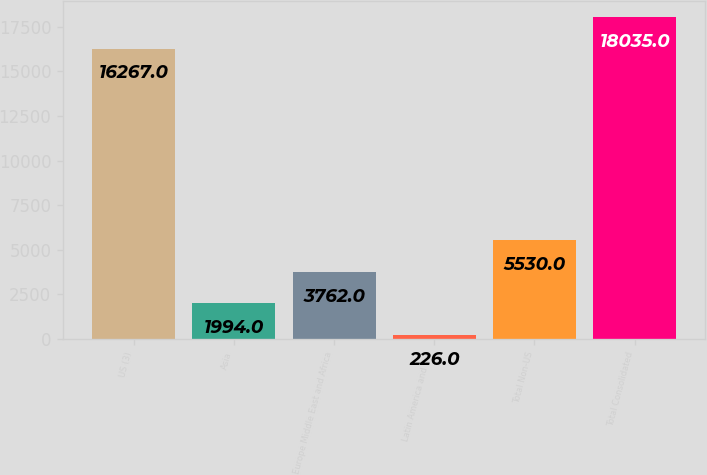Convert chart to OTSL. <chart><loc_0><loc_0><loc_500><loc_500><bar_chart><fcel>US (3)<fcel>Asia<fcel>Europe Middle East and Africa<fcel>Latin America and the<fcel>Total Non-US<fcel>Total Consolidated<nl><fcel>16267<fcel>1994<fcel>3762<fcel>226<fcel>5530<fcel>18035<nl></chart> 